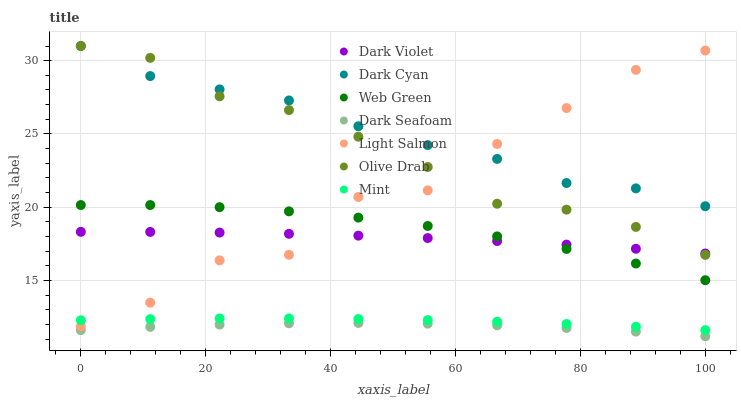Does Dark Seafoam have the minimum area under the curve?
Answer yes or no. Yes. Does Dark Cyan have the maximum area under the curve?
Answer yes or no. Yes. Does Web Green have the minimum area under the curve?
Answer yes or no. No. Does Web Green have the maximum area under the curve?
Answer yes or no. No. Is Mint the smoothest?
Answer yes or no. Yes. Is Light Salmon the roughest?
Answer yes or no. Yes. Is Web Green the smoothest?
Answer yes or no. No. Is Web Green the roughest?
Answer yes or no. No. Does Dark Seafoam have the lowest value?
Answer yes or no. Yes. Does Web Green have the lowest value?
Answer yes or no. No. Does Olive Drab have the highest value?
Answer yes or no. Yes. Does Web Green have the highest value?
Answer yes or no. No. Is Mint less than Web Green?
Answer yes or no. Yes. Is Dark Cyan greater than Web Green?
Answer yes or no. Yes. Does Light Salmon intersect Olive Drab?
Answer yes or no. Yes. Is Light Salmon less than Olive Drab?
Answer yes or no. No. Is Light Salmon greater than Olive Drab?
Answer yes or no. No. Does Mint intersect Web Green?
Answer yes or no. No. 